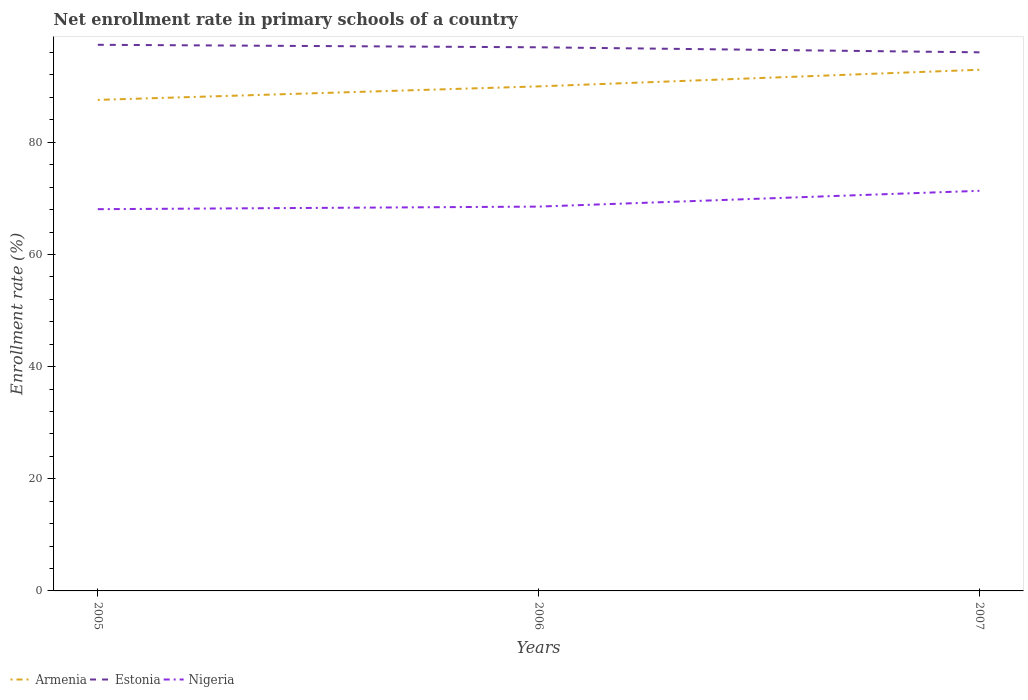Is the number of lines equal to the number of legend labels?
Make the answer very short. Yes. Across all years, what is the maximum enrollment rate in primary schools in Armenia?
Provide a short and direct response. 87.56. In which year was the enrollment rate in primary schools in Estonia maximum?
Give a very brief answer. 2007. What is the total enrollment rate in primary schools in Armenia in the graph?
Your answer should be compact. -2.96. What is the difference between the highest and the second highest enrollment rate in primary schools in Estonia?
Your answer should be compact. 1.34. How many lines are there?
Give a very brief answer. 3. How many years are there in the graph?
Offer a terse response. 3. Does the graph contain grids?
Give a very brief answer. No. How many legend labels are there?
Provide a succinct answer. 3. What is the title of the graph?
Offer a very short reply. Net enrollment rate in primary schools of a country. Does "High income: nonOECD" appear as one of the legend labels in the graph?
Offer a very short reply. No. What is the label or title of the Y-axis?
Your answer should be compact. Enrollment rate (%). What is the Enrollment rate (%) in Armenia in 2005?
Offer a very short reply. 87.56. What is the Enrollment rate (%) in Estonia in 2005?
Keep it short and to the point. 97.38. What is the Enrollment rate (%) in Nigeria in 2005?
Make the answer very short. 68.07. What is the Enrollment rate (%) in Armenia in 2006?
Give a very brief answer. 89.97. What is the Enrollment rate (%) in Estonia in 2006?
Ensure brevity in your answer.  96.94. What is the Enrollment rate (%) in Nigeria in 2006?
Offer a very short reply. 68.53. What is the Enrollment rate (%) in Armenia in 2007?
Offer a terse response. 92.93. What is the Enrollment rate (%) of Estonia in 2007?
Give a very brief answer. 96.04. What is the Enrollment rate (%) of Nigeria in 2007?
Ensure brevity in your answer.  71.35. Across all years, what is the maximum Enrollment rate (%) in Armenia?
Ensure brevity in your answer.  92.93. Across all years, what is the maximum Enrollment rate (%) in Estonia?
Offer a very short reply. 97.38. Across all years, what is the maximum Enrollment rate (%) of Nigeria?
Your answer should be very brief. 71.35. Across all years, what is the minimum Enrollment rate (%) of Armenia?
Your answer should be very brief. 87.56. Across all years, what is the minimum Enrollment rate (%) in Estonia?
Ensure brevity in your answer.  96.04. Across all years, what is the minimum Enrollment rate (%) in Nigeria?
Ensure brevity in your answer.  68.07. What is the total Enrollment rate (%) in Armenia in the graph?
Offer a very short reply. 270.46. What is the total Enrollment rate (%) of Estonia in the graph?
Make the answer very short. 290.36. What is the total Enrollment rate (%) in Nigeria in the graph?
Keep it short and to the point. 207.95. What is the difference between the Enrollment rate (%) in Armenia in 2005 and that in 2006?
Your answer should be compact. -2.41. What is the difference between the Enrollment rate (%) in Estonia in 2005 and that in 2006?
Make the answer very short. 0.45. What is the difference between the Enrollment rate (%) of Nigeria in 2005 and that in 2006?
Make the answer very short. -0.46. What is the difference between the Enrollment rate (%) of Armenia in 2005 and that in 2007?
Your answer should be compact. -5.37. What is the difference between the Enrollment rate (%) in Estonia in 2005 and that in 2007?
Your answer should be very brief. 1.34. What is the difference between the Enrollment rate (%) in Nigeria in 2005 and that in 2007?
Your response must be concise. -3.28. What is the difference between the Enrollment rate (%) in Armenia in 2006 and that in 2007?
Your response must be concise. -2.96. What is the difference between the Enrollment rate (%) of Estonia in 2006 and that in 2007?
Make the answer very short. 0.9. What is the difference between the Enrollment rate (%) of Nigeria in 2006 and that in 2007?
Your response must be concise. -2.82. What is the difference between the Enrollment rate (%) in Armenia in 2005 and the Enrollment rate (%) in Estonia in 2006?
Ensure brevity in your answer.  -9.38. What is the difference between the Enrollment rate (%) of Armenia in 2005 and the Enrollment rate (%) of Nigeria in 2006?
Your response must be concise. 19.03. What is the difference between the Enrollment rate (%) of Estonia in 2005 and the Enrollment rate (%) of Nigeria in 2006?
Your response must be concise. 28.85. What is the difference between the Enrollment rate (%) of Armenia in 2005 and the Enrollment rate (%) of Estonia in 2007?
Your answer should be very brief. -8.48. What is the difference between the Enrollment rate (%) in Armenia in 2005 and the Enrollment rate (%) in Nigeria in 2007?
Offer a very short reply. 16.21. What is the difference between the Enrollment rate (%) of Estonia in 2005 and the Enrollment rate (%) of Nigeria in 2007?
Your answer should be compact. 26.04. What is the difference between the Enrollment rate (%) of Armenia in 2006 and the Enrollment rate (%) of Estonia in 2007?
Offer a terse response. -6.07. What is the difference between the Enrollment rate (%) of Armenia in 2006 and the Enrollment rate (%) of Nigeria in 2007?
Your answer should be very brief. 18.62. What is the difference between the Enrollment rate (%) in Estonia in 2006 and the Enrollment rate (%) in Nigeria in 2007?
Give a very brief answer. 25.59. What is the average Enrollment rate (%) in Armenia per year?
Give a very brief answer. 90.15. What is the average Enrollment rate (%) of Estonia per year?
Make the answer very short. 96.79. What is the average Enrollment rate (%) in Nigeria per year?
Provide a short and direct response. 69.32. In the year 2005, what is the difference between the Enrollment rate (%) in Armenia and Enrollment rate (%) in Estonia?
Keep it short and to the point. -9.82. In the year 2005, what is the difference between the Enrollment rate (%) in Armenia and Enrollment rate (%) in Nigeria?
Your response must be concise. 19.49. In the year 2005, what is the difference between the Enrollment rate (%) in Estonia and Enrollment rate (%) in Nigeria?
Your answer should be very brief. 29.31. In the year 2006, what is the difference between the Enrollment rate (%) of Armenia and Enrollment rate (%) of Estonia?
Provide a short and direct response. -6.97. In the year 2006, what is the difference between the Enrollment rate (%) in Armenia and Enrollment rate (%) in Nigeria?
Provide a succinct answer. 21.44. In the year 2006, what is the difference between the Enrollment rate (%) in Estonia and Enrollment rate (%) in Nigeria?
Provide a short and direct response. 28.41. In the year 2007, what is the difference between the Enrollment rate (%) of Armenia and Enrollment rate (%) of Estonia?
Give a very brief answer. -3.11. In the year 2007, what is the difference between the Enrollment rate (%) of Armenia and Enrollment rate (%) of Nigeria?
Your answer should be compact. 21.58. In the year 2007, what is the difference between the Enrollment rate (%) in Estonia and Enrollment rate (%) in Nigeria?
Your response must be concise. 24.69. What is the ratio of the Enrollment rate (%) of Armenia in 2005 to that in 2006?
Your response must be concise. 0.97. What is the ratio of the Enrollment rate (%) of Armenia in 2005 to that in 2007?
Make the answer very short. 0.94. What is the ratio of the Enrollment rate (%) in Estonia in 2005 to that in 2007?
Provide a succinct answer. 1.01. What is the ratio of the Enrollment rate (%) of Nigeria in 2005 to that in 2007?
Your answer should be very brief. 0.95. What is the ratio of the Enrollment rate (%) in Armenia in 2006 to that in 2007?
Ensure brevity in your answer.  0.97. What is the ratio of the Enrollment rate (%) of Estonia in 2006 to that in 2007?
Ensure brevity in your answer.  1.01. What is the ratio of the Enrollment rate (%) of Nigeria in 2006 to that in 2007?
Your answer should be compact. 0.96. What is the difference between the highest and the second highest Enrollment rate (%) in Armenia?
Your answer should be compact. 2.96. What is the difference between the highest and the second highest Enrollment rate (%) in Estonia?
Ensure brevity in your answer.  0.45. What is the difference between the highest and the second highest Enrollment rate (%) of Nigeria?
Make the answer very short. 2.82. What is the difference between the highest and the lowest Enrollment rate (%) in Armenia?
Ensure brevity in your answer.  5.37. What is the difference between the highest and the lowest Enrollment rate (%) in Estonia?
Your answer should be very brief. 1.34. What is the difference between the highest and the lowest Enrollment rate (%) in Nigeria?
Provide a short and direct response. 3.28. 